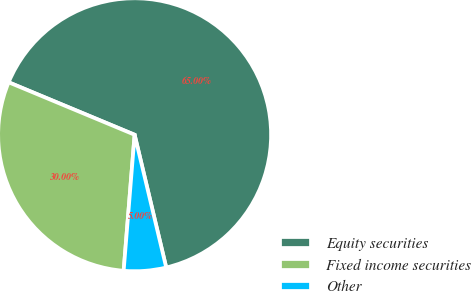Convert chart. <chart><loc_0><loc_0><loc_500><loc_500><pie_chart><fcel>Equity securities<fcel>Fixed income securities<fcel>Other<nl><fcel>65.0%<fcel>30.0%<fcel>5.0%<nl></chart> 